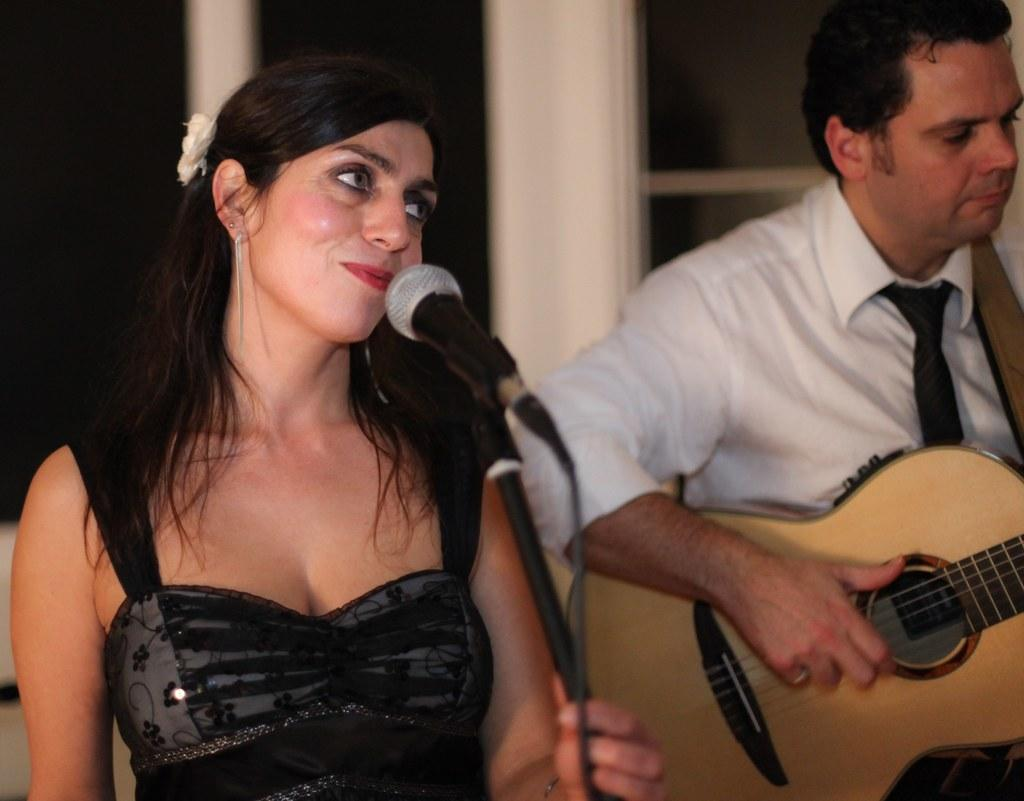What is the woman in the image doing? The woman is speaking with the help of a microphone. What is the man in the image doing? The man is playing a guitar. How is the woman amplifying her voice in the image? The woman is using a microphone to amplify her voice. What instrument is the man playing in the image? The man is playing a guitar. What type of dinner is being prepared in the image? There is no reference to dinner or any food preparation in the image. What type of pleasure is the man experiencing while playing the guitar in the image? There is no indication of the man's emotions or experiences while playing the guitar in the image. 